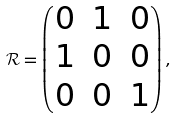<formula> <loc_0><loc_0><loc_500><loc_500>\mathcal { R } = \begin{pmatrix} 0 & 1 & 0 \\ 1 & 0 & 0 \\ 0 & 0 & 1 \end{pmatrix} ,</formula> 